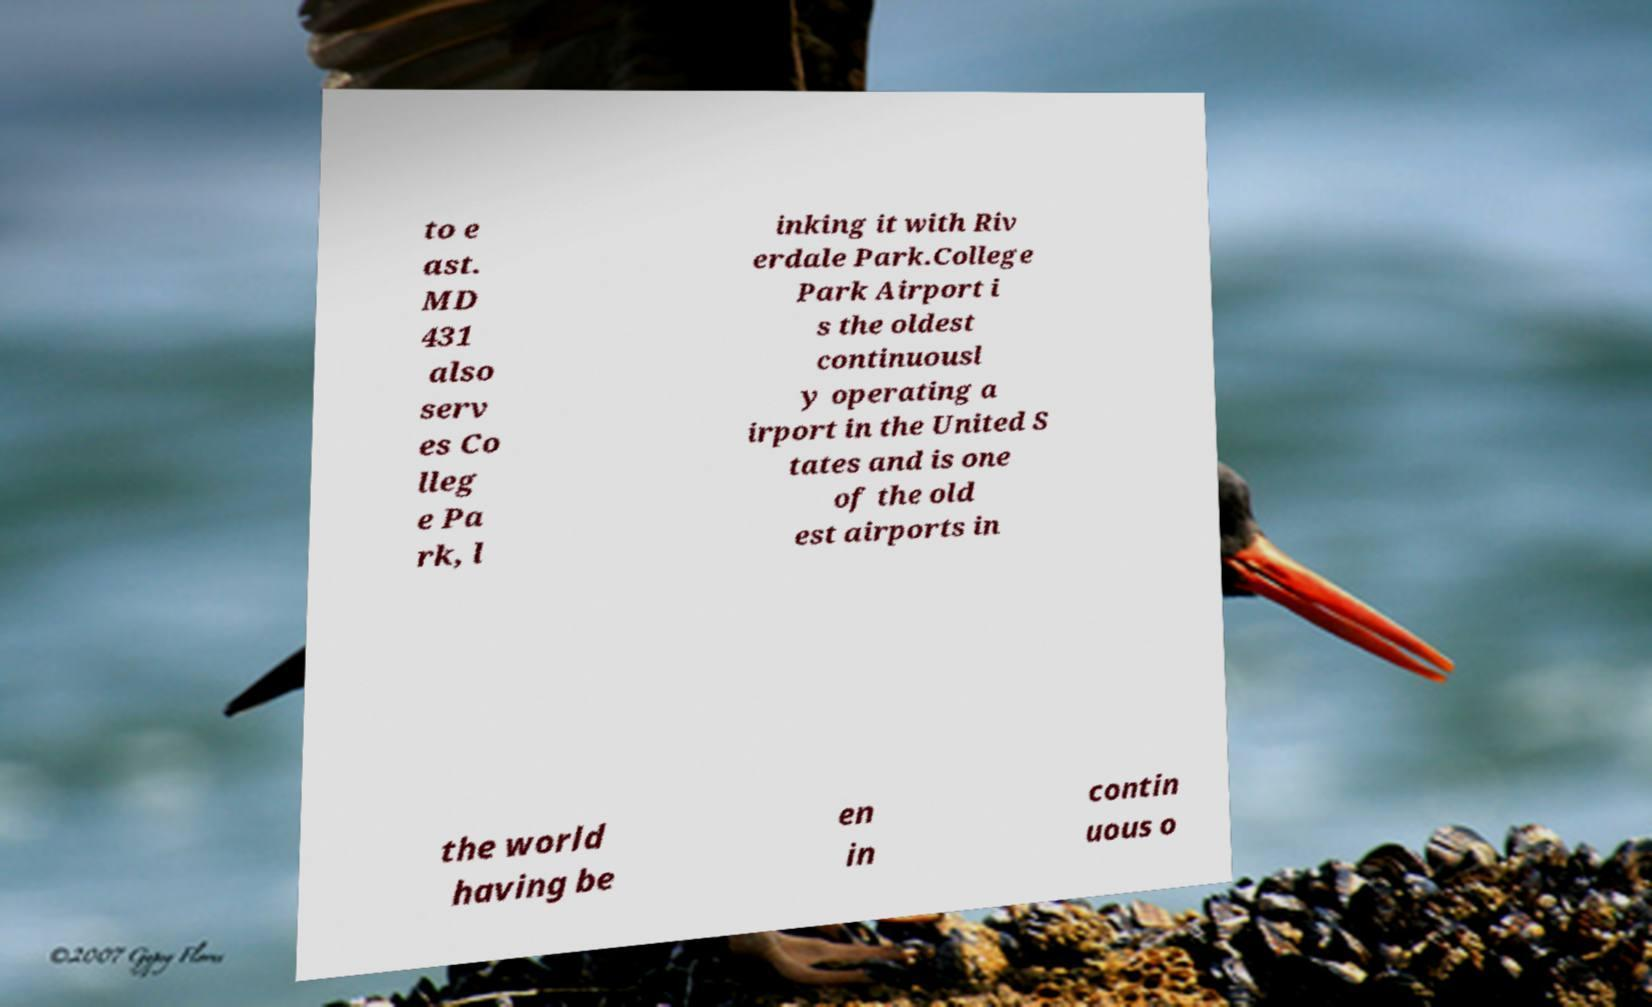Can you accurately transcribe the text from the provided image for me? to e ast. MD 431 also serv es Co lleg e Pa rk, l inking it with Riv erdale Park.College Park Airport i s the oldest continuousl y operating a irport in the United S tates and is one of the old est airports in the world having be en in contin uous o 